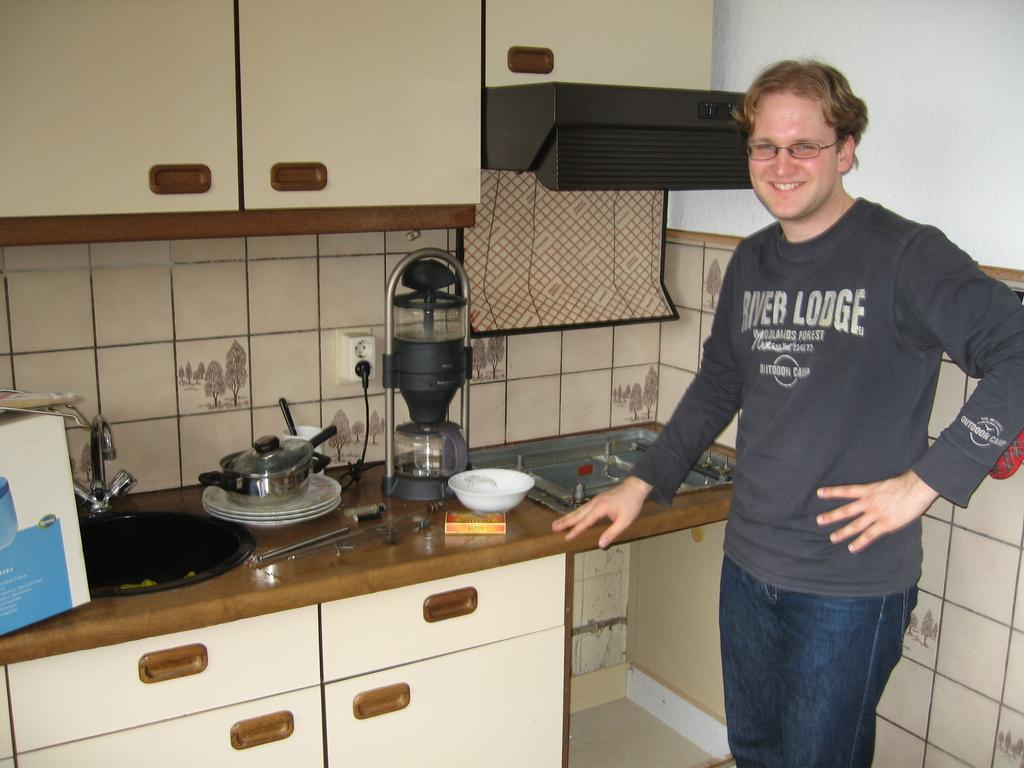<image>
Offer a succinct explanation of the picture presented. A blonde man wearing a River Lodge long sleeve shirt. 